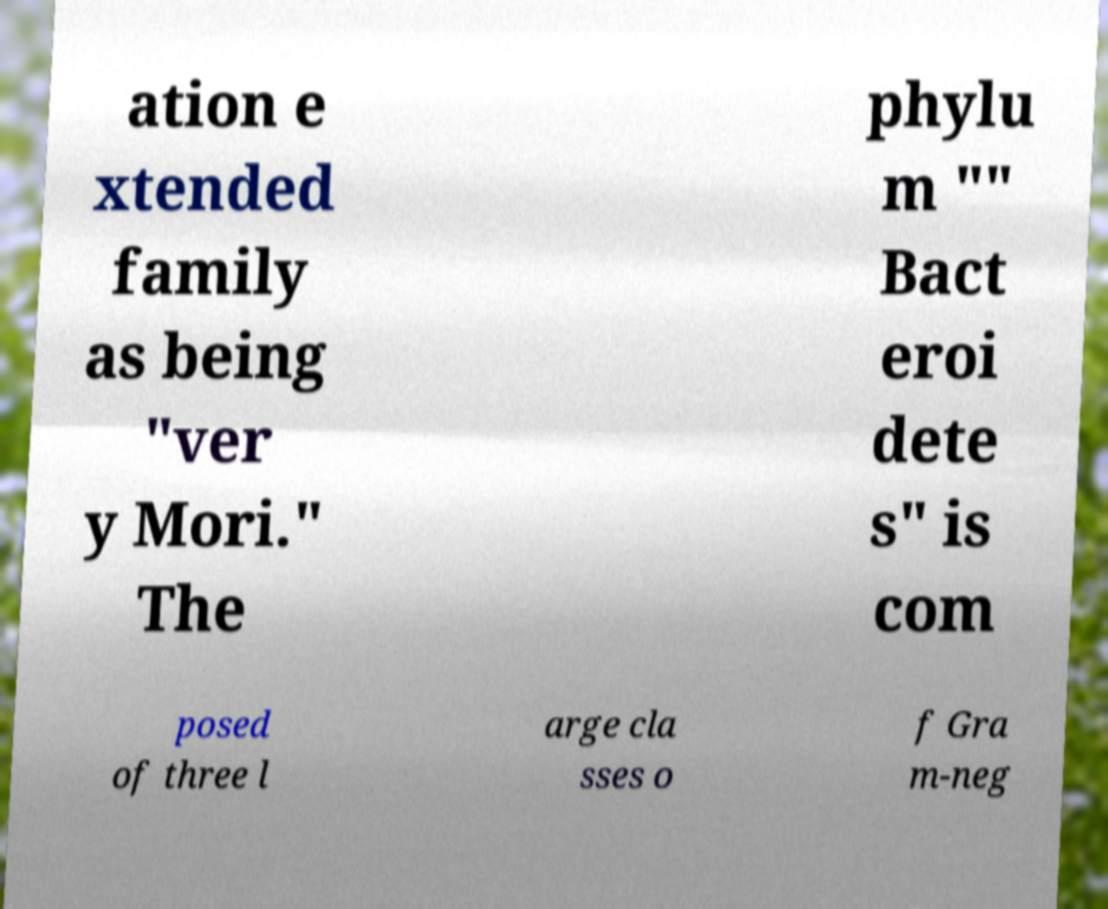Please identify and transcribe the text found in this image. ation e xtended family as being "ver y Mori." The phylu m "" Bact eroi dete s" is com posed of three l arge cla sses o f Gra m-neg 